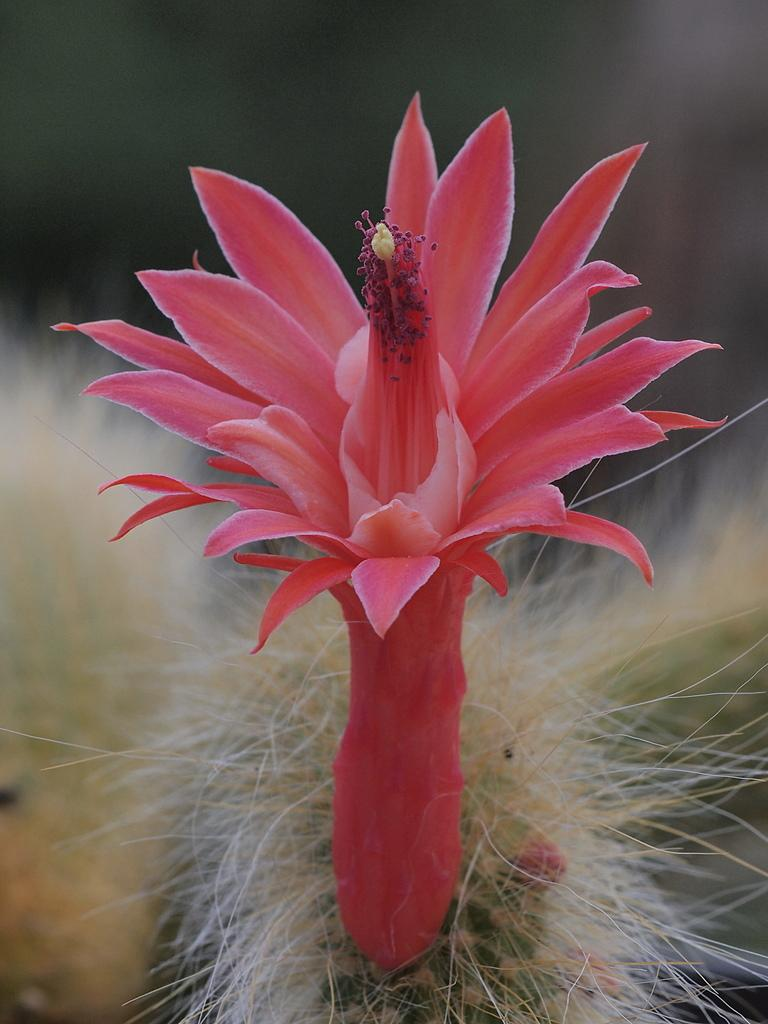What type of flower is in the image? There is a pink flower in the image. What color are the items at the bottom of the image? The items at the bottom of the image are white. How would you describe the background of the image? The background of the image is blurred. What type of wrench is being used by the man in the image? There is no man or wrench present in the image. What type of apparel is the man wearing in the image? There is no man present in the image, so it is not possible to describe his apparel. 